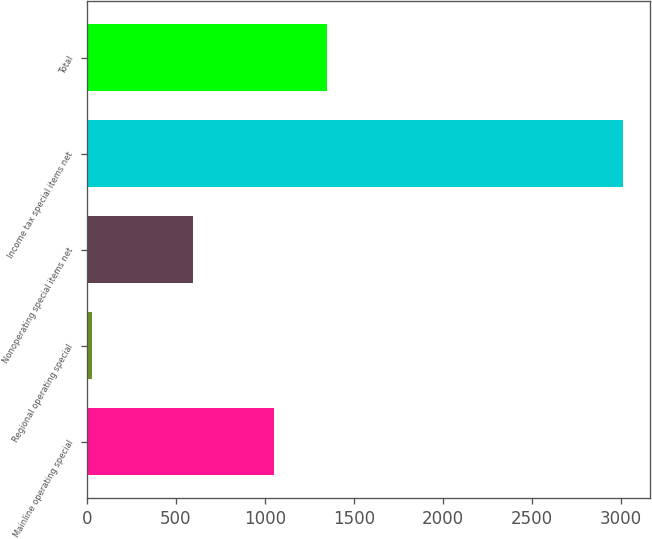Convert chart. <chart><loc_0><loc_0><loc_500><loc_500><bar_chart><fcel>Mainline operating special<fcel>Regional operating special<fcel>Nonoperating special items net<fcel>Income tax special items net<fcel>Total<nl><fcel>1051<fcel>29<fcel>594<fcel>3015<fcel>1349.6<nl></chart> 